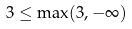Convert formula to latex. <formula><loc_0><loc_0><loc_500><loc_500>3 \leq \max ( 3 , - \infty )</formula> 